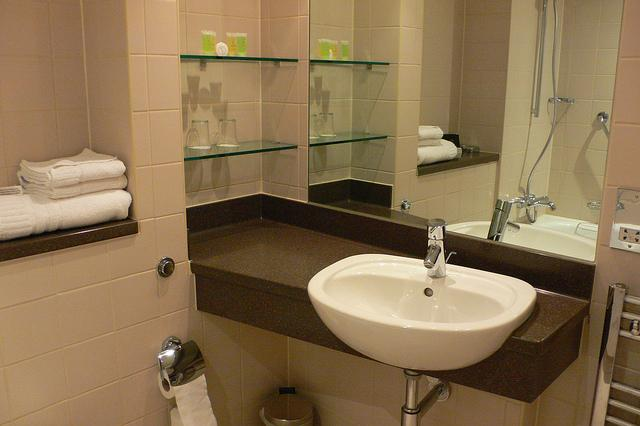What happens if you pull the lever in the middle of the photo? water comes 